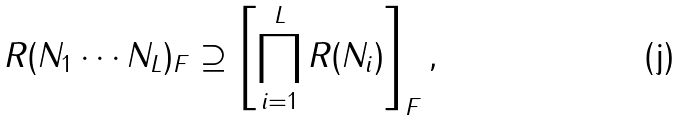Convert formula to latex. <formula><loc_0><loc_0><loc_500><loc_500>R ( N _ { 1 } \cdots N _ { L } ) _ { F } \supseteq \left [ \prod _ { i = 1 } ^ { L } R ( N _ { i } ) \right ] _ { F } ,</formula> 